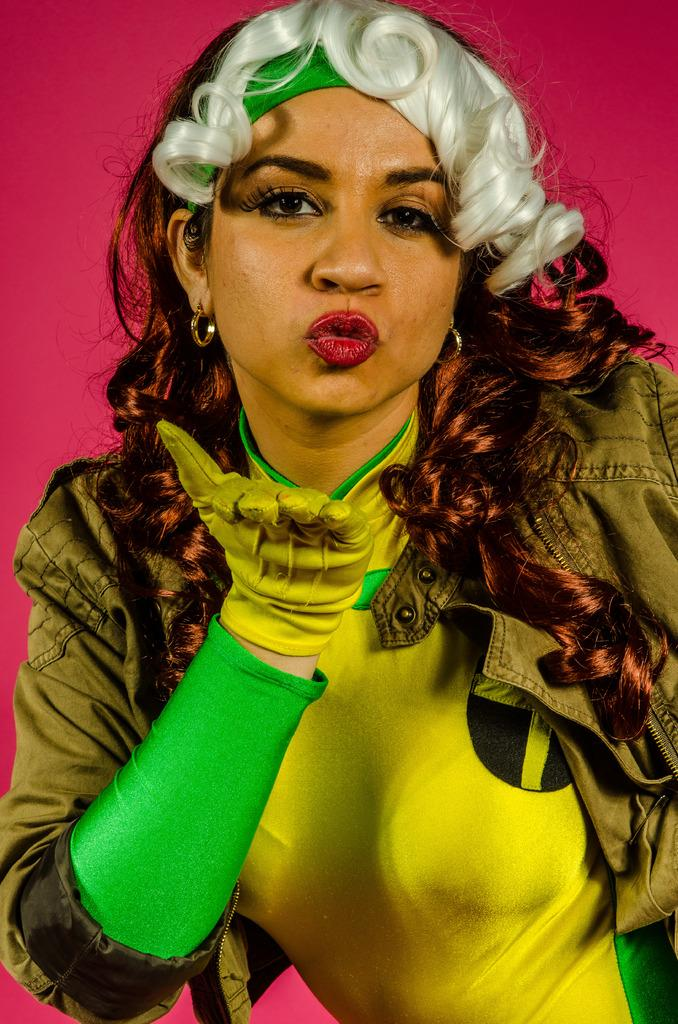Who is the main subject in the image? There is a woman in the picture. Where is the woman located in the image? The woman is in the middle of the image. What type of clothing is the woman wearing? The woman is wearing a coat and a t-shirt. What type of bite can be seen on the woman's arm in the image? There is no bite visible on the woman's arm in the image. 